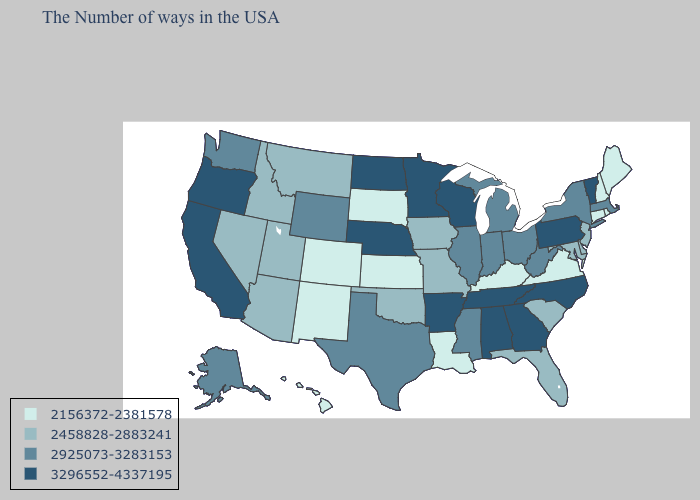Name the states that have a value in the range 2156372-2381578?
Keep it brief. Maine, Rhode Island, New Hampshire, Connecticut, Virginia, Kentucky, Louisiana, Kansas, South Dakota, Colorado, New Mexico, Hawaii. Name the states that have a value in the range 2925073-3283153?
Quick response, please. Massachusetts, New York, West Virginia, Ohio, Michigan, Indiana, Illinois, Mississippi, Texas, Wyoming, Washington, Alaska. Name the states that have a value in the range 2156372-2381578?
Concise answer only. Maine, Rhode Island, New Hampshire, Connecticut, Virginia, Kentucky, Louisiana, Kansas, South Dakota, Colorado, New Mexico, Hawaii. Does Florida have a lower value than Michigan?
Short answer required. Yes. What is the value of North Dakota?
Concise answer only. 3296552-4337195. Does Illinois have a lower value than Oregon?
Give a very brief answer. Yes. Among the states that border West Virginia , does Pennsylvania have the lowest value?
Quick response, please. No. Does the map have missing data?
Write a very short answer. No. Does Maine have the highest value in the Northeast?
Concise answer only. No. Name the states that have a value in the range 2925073-3283153?
Short answer required. Massachusetts, New York, West Virginia, Ohio, Michigan, Indiana, Illinois, Mississippi, Texas, Wyoming, Washington, Alaska. What is the lowest value in the South?
Answer briefly. 2156372-2381578. What is the value of North Dakota?
Quick response, please. 3296552-4337195. Which states have the highest value in the USA?
Quick response, please. Vermont, Pennsylvania, North Carolina, Georgia, Alabama, Tennessee, Wisconsin, Arkansas, Minnesota, Nebraska, North Dakota, California, Oregon. Does the first symbol in the legend represent the smallest category?
Answer briefly. Yes. Name the states that have a value in the range 3296552-4337195?
Short answer required. Vermont, Pennsylvania, North Carolina, Georgia, Alabama, Tennessee, Wisconsin, Arkansas, Minnesota, Nebraska, North Dakota, California, Oregon. 